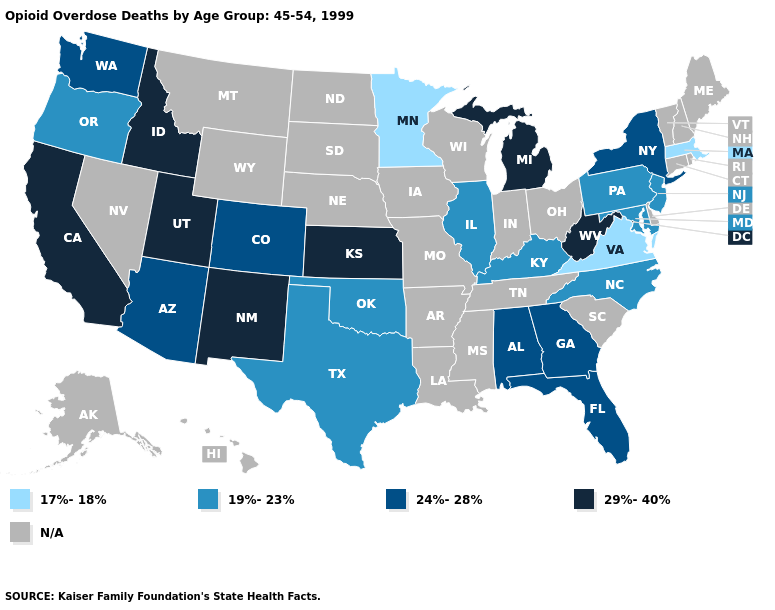What is the value of Wisconsin?
Short answer required. N/A. How many symbols are there in the legend?
Short answer required. 5. Which states hav the highest value in the West?
Concise answer only. California, Idaho, New Mexico, Utah. Name the states that have a value in the range 17%-18%?
Concise answer only. Massachusetts, Minnesota, Virginia. What is the value of Delaware?
Short answer required. N/A. What is the value of Michigan?
Concise answer only. 29%-40%. What is the lowest value in the USA?
Be succinct. 17%-18%. Is the legend a continuous bar?
Answer briefly. No. Name the states that have a value in the range N/A?
Short answer required. Alaska, Arkansas, Connecticut, Delaware, Hawaii, Indiana, Iowa, Louisiana, Maine, Mississippi, Missouri, Montana, Nebraska, Nevada, New Hampshire, North Dakota, Ohio, Rhode Island, South Carolina, South Dakota, Tennessee, Vermont, Wisconsin, Wyoming. Name the states that have a value in the range N/A?
Concise answer only. Alaska, Arkansas, Connecticut, Delaware, Hawaii, Indiana, Iowa, Louisiana, Maine, Mississippi, Missouri, Montana, Nebraska, Nevada, New Hampshire, North Dakota, Ohio, Rhode Island, South Carolina, South Dakota, Tennessee, Vermont, Wisconsin, Wyoming. Which states have the lowest value in the USA?
Write a very short answer. Massachusetts, Minnesota, Virginia. Name the states that have a value in the range 17%-18%?
Answer briefly. Massachusetts, Minnesota, Virginia. 